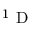<formula> <loc_0><loc_0><loc_500><loc_500>^ { 1 } D</formula> 